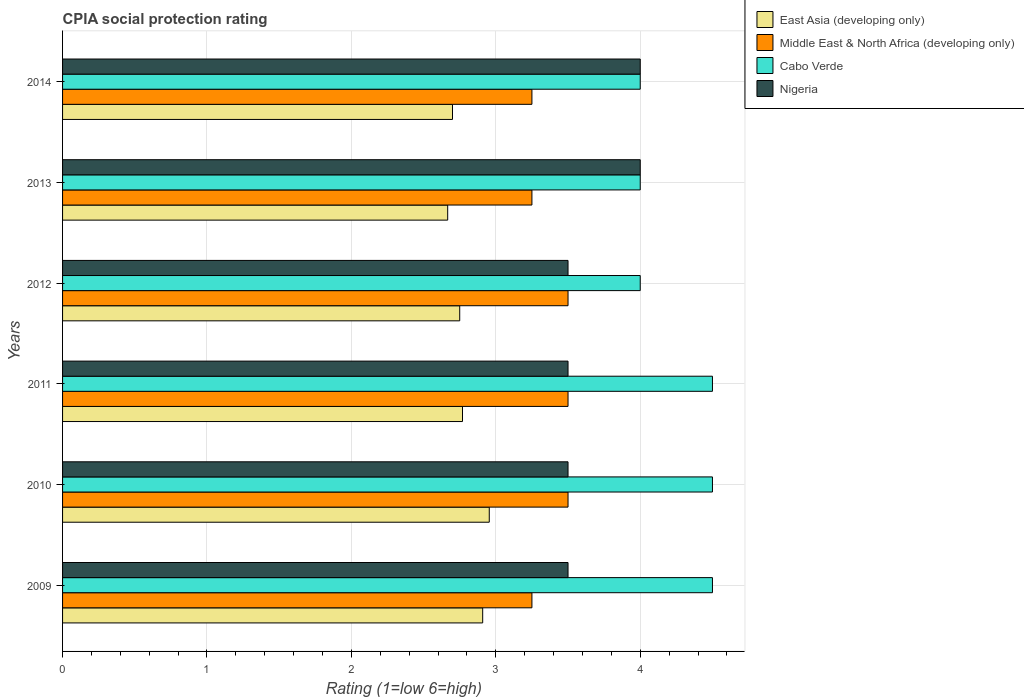How many groups of bars are there?
Your answer should be compact. 6. Are the number of bars on each tick of the Y-axis equal?
Ensure brevity in your answer.  Yes. How many bars are there on the 2nd tick from the bottom?
Make the answer very short. 4. What is the label of the 4th group of bars from the top?
Ensure brevity in your answer.  2011. What is the CPIA rating in Middle East & North Africa (developing only) in 2014?
Your answer should be very brief. 3.25. In which year was the CPIA rating in Nigeria maximum?
Provide a succinct answer. 2013. In which year was the CPIA rating in Middle East & North Africa (developing only) minimum?
Your answer should be very brief. 2009. What is the total CPIA rating in Cabo Verde in the graph?
Your answer should be compact. 25.5. What is the difference between the CPIA rating in Nigeria in 2013 and the CPIA rating in Cabo Verde in 2012?
Provide a short and direct response. 0. What is the average CPIA rating in Nigeria per year?
Your answer should be very brief. 3.67. In the year 2014, what is the difference between the CPIA rating in Nigeria and CPIA rating in East Asia (developing only)?
Offer a very short reply. 1.3. In how many years, is the CPIA rating in Middle East & North Africa (developing only) greater than 2.6 ?
Offer a terse response. 6. What is the difference between the highest and the second highest CPIA rating in East Asia (developing only)?
Your answer should be very brief. 0.05. What is the difference between the highest and the lowest CPIA rating in Cabo Verde?
Ensure brevity in your answer.  0.5. Is the sum of the CPIA rating in Middle East & North Africa (developing only) in 2010 and 2012 greater than the maximum CPIA rating in Cabo Verde across all years?
Provide a succinct answer. Yes. Is it the case that in every year, the sum of the CPIA rating in Cabo Verde and CPIA rating in Nigeria is greater than the sum of CPIA rating in Middle East & North Africa (developing only) and CPIA rating in East Asia (developing only)?
Provide a short and direct response. Yes. What does the 4th bar from the top in 2013 represents?
Give a very brief answer. East Asia (developing only). What does the 1st bar from the bottom in 2011 represents?
Offer a very short reply. East Asia (developing only). Is it the case that in every year, the sum of the CPIA rating in Cabo Verde and CPIA rating in East Asia (developing only) is greater than the CPIA rating in Nigeria?
Make the answer very short. Yes. How many bars are there?
Ensure brevity in your answer.  24. What is the difference between two consecutive major ticks on the X-axis?
Make the answer very short. 1. Does the graph contain any zero values?
Your answer should be very brief. No. Does the graph contain grids?
Keep it short and to the point. Yes. How many legend labels are there?
Your answer should be compact. 4. What is the title of the graph?
Ensure brevity in your answer.  CPIA social protection rating. Does "South Asia" appear as one of the legend labels in the graph?
Your answer should be compact. No. What is the Rating (1=low 6=high) of East Asia (developing only) in 2009?
Keep it short and to the point. 2.91. What is the Rating (1=low 6=high) in Middle East & North Africa (developing only) in 2009?
Offer a terse response. 3.25. What is the Rating (1=low 6=high) of East Asia (developing only) in 2010?
Provide a succinct answer. 2.95. What is the Rating (1=low 6=high) in Middle East & North Africa (developing only) in 2010?
Offer a terse response. 3.5. What is the Rating (1=low 6=high) in Cabo Verde in 2010?
Make the answer very short. 4.5. What is the Rating (1=low 6=high) of East Asia (developing only) in 2011?
Your answer should be compact. 2.77. What is the Rating (1=low 6=high) of Nigeria in 2011?
Provide a succinct answer. 3.5. What is the Rating (1=low 6=high) in East Asia (developing only) in 2012?
Your answer should be very brief. 2.75. What is the Rating (1=low 6=high) in Cabo Verde in 2012?
Your answer should be very brief. 4. What is the Rating (1=low 6=high) in East Asia (developing only) in 2013?
Your answer should be very brief. 2.67. What is the Rating (1=low 6=high) in Nigeria in 2013?
Keep it short and to the point. 4. What is the Rating (1=low 6=high) in Middle East & North Africa (developing only) in 2014?
Provide a succinct answer. 3.25. What is the Rating (1=low 6=high) in Nigeria in 2014?
Provide a succinct answer. 4. Across all years, what is the maximum Rating (1=low 6=high) of East Asia (developing only)?
Make the answer very short. 2.95. Across all years, what is the maximum Rating (1=low 6=high) in Cabo Verde?
Provide a succinct answer. 4.5. Across all years, what is the maximum Rating (1=low 6=high) of Nigeria?
Make the answer very short. 4. Across all years, what is the minimum Rating (1=low 6=high) of East Asia (developing only)?
Keep it short and to the point. 2.67. Across all years, what is the minimum Rating (1=low 6=high) of Middle East & North Africa (developing only)?
Keep it short and to the point. 3.25. Across all years, what is the minimum Rating (1=low 6=high) in Cabo Verde?
Provide a succinct answer. 4. Across all years, what is the minimum Rating (1=low 6=high) of Nigeria?
Your response must be concise. 3.5. What is the total Rating (1=low 6=high) of East Asia (developing only) in the graph?
Offer a very short reply. 16.75. What is the total Rating (1=low 6=high) in Middle East & North Africa (developing only) in the graph?
Offer a very short reply. 20.25. What is the total Rating (1=low 6=high) of Cabo Verde in the graph?
Make the answer very short. 25.5. What is the difference between the Rating (1=low 6=high) in East Asia (developing only) in 2009 and that in 2010?
Your answer should be compact. -0.05. What is the difference between the Rating (1=low 6=high) in Cabo Verde in 2009 and that in 2010?
Provide a short and direct response. 0. What is the difference between the Rating (1=low 6=high) of East Asia (developing only) in 2009 and that in 2011?
Offer a terse response. 0.14. What is the difference between the Rating (1=low 6=high) in Middle East & North Africa (developing only) in 2009 and that in 2011?
Make the answer very short. -0.25. What is the difference between the Rating (1=low 6=high) in East Asia (developing only) in 2009 and that in 2012?
Your answer should be very brief. 0.16. What is the difference between the Rating (1=low 6=high) in Middle East & North Africa (developing only) in 2009 and that in 2012?
Offer a very short reply. -0.25. What is the difference between the Rating (1=low 6=high) in Nigeria in 2009 and that in 2012?
Give a very brief answer. 0. What is the difference between the Rating (1=low 6=high) in East Asia (developing only) in 2009 and that in 2013?
Your response must be concise. 0.24. What is the difference between the Rating (1=low 6=high) in East Asia (developing only) in 2009 and that in 2014?
Your answer should be very brief. 0.21. What is the difference between the Rating (1=low 6=high) in East Asia (developing only) in 2010 and that in 2011?
Provide a succinct answer. 0.19. What is the difference between the Rating (1=low 6=high) of Cabo Verde in 2010 and that in 2011?
Ensure brevity in your answer.  0. What is the difference between the Rating (1=low 6=high) in East Asia (developing only) in 2010 and that in 2012?
Your answer should be compact. 0.2. What is the difference between the Rating (1=low 6=high) in Cabo Verde in 2010 and that in 2012?
Your answer should be compact. 0.5. What is the difference between the Rating (1=low 6=high) in East Asia (developing only) in 2010 and that in 2013?
Provide a short and direct response. 0.29. What is the difference between the Rating (1=low 6=high) of Middle East & North Africa (developing only) in 2010 and that in 2013?
Offer a terse response. 0.25. What is the difference between the Rating (1=low 6=high) in Cabo Verde in 2010 and that in 2013?
Make the answer very short. 0.5. What is the difference between the Rating (1=low 6=high) in East Asia (developing only) in 2010 and that in 2014?
Ensure brevity in your answer.  0.25. What is the difference between the Rating (1=low 6=high) of Cabo Verde in 2010 and that in 2014?
Your answer should be very brief. 0.5. What is the difference between the Rating (1=low 6=high) of East Asia (developing only) in 2011 and that in 2012?
Ensure brevity in your answer.  0.02. What is the difference between the Rating (1=low 6=high) of Middle East & North Africa (developing only) in 2011 and that in 2012?
Offer a terse response. 0. What is the difference between the Rating (1=low 6=high) in East Asia (developing only) in 2011 and that in 2013?
Provide a short and direct response. 0.1. What is the difference between the Rating (1=low 6=high) of East Asia (developing only) in 2011 and that in 2014?
Provide a succinct answer. 0.07. What is the difference between the Rating (1=low 6=high) of Middle East & North Africa (developing only) in 2011 and that in 2014?
Your answer should be very brief. 0.25. What is the difference between the Rating (1=low 6=high) in Cabo Verde in 2011 and that in 2014?
Keep it short and to the point. 0.5. What is the difference between the Rating (1=low 6=high) in East Asia (developing only) in 2012 and that in 2013?
Make the answer very short. 0.08. What is the difference between the Rating (1=low 6=high) in Middle East & North Africa (developing only) in 2012 and that in 2013?
Offer a terse response. 0.25. What is the difference between the Rating (1=low 6=high) in Nigeria in 2012 and that in 2013?
Your response must be concise. -0.5. What is the difference between the Rating (1=low 6=high) of East Asia (developing only) in 2012 and that in 2014?
Provide a short and direct response. 0.05. What is the difference between the Rating (1=low 6=high) of East Asia (developing only) in 2013 and that in 2014?
Provide a succinct answer. -0.03. What is the difference between the Rating (1=low 6=high) in East Asia (developing only) in 2009 and the Rating (1=low 6=high) in Middle East & North Africa (developing only) in 2010?
Your answer should be compact. -0.59. What is the difference between the Rating (1=low 6=high) in East Asia (developing only) in 2009 and the Rating (1=low 6=high) in Cabo Verde in 2010?
Keep it short and to the point. -1.59. What is the difference between the Rating (1=low 6=high) in East Asia (developing only) in 2009 and the Rating (1=low 6=high) in Nigeria in 2010?
Your response must be concise. -0.59. What is the difference between the Rating (1=low 6=high) in Middle East & North Africa (developing only) in 2009 and the Rating (1=low 6=high) in Cabo Verde in 2010?
Provide a short and direct response. -1.25. What is the difference between the Rating (1=low 6=high) of Cabo Verde in 2009 and the Rating (1=low 6=high) of Nigeria in 2010?
Make the answer very short. 1. What is the difference between the Rating (1=low 6=high) in East Asia (developing only) in 2009 and the Rating (1=low 6=high) in Middle East & North Africa (developing only) in 2011?
Ensure brevity in your answer.  -0.59. What is the difference between the Rating (1=low 6=high) of East Asia (developing only) in 2009 and the Rating (1=low 6=high) of Cabo Verde in 2011?
Your response must be concise. -1.59. What is the difference between the Rating (1=low 6=high) in East Asia (developing only) in 2009 and the Rating (1=low 6=high) in Nigeria in 2011?
Give a very brief answer. -0.59. What is the difference between the Rating (1=low 6=high) of Middle East & North Africa (developing only) in 2009 and the Rating (1=low 6=high) of Cabo Verde in 2011?
Offer a very short reply. -1.25. What is the difference between the Rating (1=low 6=high) in Cabo Verde in 2009 and the Rating (1=low 6=high) in Nigeria in 2011?
Your response must be concise. 1. What is the difference between the Rating (1=low 6=high) in East Asia (developing only) in 2009 and the Rating (1=low 6=high) in Middle East & North Africa (developing only) in 2012?
Provide a short and direct response. -0.59. What is the difference between the Rating (1=low 6=high) in East Asia (developing only) in 2009 and the Rating (1=low 6=high) in Cabo Verde in 2012?
Keep it short and to the point. -1.09. What is the difference between the Rating (1=low 6=high) in East Asia (developing only) in 2009 and the Rating (1=low 6=high) in Nigeria in 2012?
Offer a very short reply. -0.59. What is the difference between the Rating (1=low 6=high) in Middle East & North Africa (developing only) in 2009 and the Rating (1=low 6=high) in Cabo Verde in 2012?
Your answer should be very brief. -0.75. What is the difference between the Rating (1=low 6=high) in Cabo Verde in 2009 and the Rating (1=low 6=high) in Nigeria in 2012?
Offer a terse response. 1. What is the difference between the Rating (1=low 6=high) of East Asia (developing only) in 2009 and the Rating (1=low 6=high) of Middle East & North Africa (developing only) in 2013?
Keep it short and to the point. -0.34. What is the difference between the Rating (1=low 6=high) of East Asia (developing only) in 2009 and the Rating (1=low 6=high) of Cabo Verde in 2013?
Provide a succinct answer. -1.09. What is the difference between the Rating (1=low 6=high) of East Asia (developing only) in 2009 and the Rating (1=low 6=high) of Nigeria in 2013?
Your answer should be compact. -1.09. What is the difference between the Rating (1=low 6=high) of Middle East & North Africa (developing only) in 2009 and the Rating (1=low 6=high) of Cabo Verde in 2013?
Provide a short and direct response. -0.75. What is the difference between the Rating (1=low 6=high) of Middle East & North Africa (developing only) in 2009 and the Rating (1=low 6=high) of Nigeria in 2013?
Offer a very short reply. -0.75. What is the difference between the Rating (1=low 6=high) of Cabo Verde in 2009 and the Rating (1=low 6=high) of Nigeria in 2013?
Make the answer very short. 0.5. What is the difference between the Rating (1=low 6=high) in East Asia (developing only) in 2009 and the Rating (1=low 6=high) in Middle East & North Africa (developing only) in 2014?
Ensure brevity in your answer.  -0.34. What is the difference between the Rating (1=low 6=high) in East Asia (developing only) in 2009 and the Rating (1=low 6=high) in Cabo Verde in 2014?
Give a very brief answer. -1.09. What is the difference between the Rating (1=low 6=high) in East Asia (developing only) in 2009 and the Rating (1=low 6=high) in Nigeria in 2014?
Make the answer very short. -1.09. What is the difference between the Rating (1=low 6=high) in Middle East & North Africa (developing only) in 2009 and the Rating (1=low 6=high) in Cabo Verde in 2014?
Make the answer very short. -0.75. What is the difference between the Rating (1=low 6=high) in Middle East & North Africa (developing only) in 2009 and the Rating (1=low 6=high) in Nigeria in 2014?
Ensure brevity in your answer.  -0.75. What is the difference between the Rating (1=low 6=high) in East Asia (developing only) in 2010 and the Rating (1=low 6=high) in Middle East & North Africa (developing only) in 2011?
Keep it short and to the point. -0.55. What is the difference between the Rating (1=low 6=high) in East Asia (developing only) in 2010 and the Rating (1=low 6=high) in Cabo Verde in 2011?
Provide a succinct answer. -1.55. What is the difference between the Rating (1=low 6=high) in East Asia (developing only) in 2010 and the Rating (1=low 6=high) in Nigeria in 2011?
Your response must be concise. -0.55. What is the difference between the Rating (1=low 6=high) in Cabo Verde in 2010 and the Rating (1=low 6=high) in Nigeria in 2011?
Provide a short and direct response. 1. What is the difference between the Rating (1=low 6=high) of East Asia (developing only) in 2010 and the Rating (1=low 6=high) of Middle East & North Africa (developing only) in 2012?
Your answer should be very brief. -0.55. What is the difference between the Rating (1=low 6=high) of East Asia (developing only) in 2010 and the Rating (1=low 6=high) of Cabo Verde in 2012?
Ensure brevity in your answer.  -1.05. What is the difference between the Rating (1=low 6=high) of East Asia (developing only) in 2010 and the Rating (1=low 6=high) of Nigeria in 2012?
Give a very brief answer. -0.55. What is the difference between the Rating (1=low 6=high) in Middle East & North Africa (developing only) in 2010 and the Rating (1=low 6=high) in Nigeria in 2012?
Your answer should be compact. 0. What is the difference between the Rating (1=low 6=high) in East Asia (developing only) in 2010 and the Rating (1=low 6=high) in Middle East & North Africa (developing only) in 2013?
Your response must be concise. -0.3. What is the difference between the Rating (1=low 6=high) in East Asia (developing only) in 2010 and the Rating (1=low 6=high) in Cabo Verde in 2013?
Provide a succinct answer. -1.05. What is the difference between the Rating (1=low 6=high) of East Asia (developing only) in 2010 and the Rating (1=low 6=high) of Nigeria in 2013?
Give a very brief answer. -1.05. What is the difference between the Rating (1=low 6=high) of Middle East & North Africa (developing only) in 2010 and the Rating (1=low 6=high) of Nigeria in 2013?
Keep it short and to the point. -0.5. What is the difference between the Rating (1=low 6=high) in Cabo Verde in 2010 and the Rating (1=low 6=high) in Nigeria in 2013?
Offer a terse response. 0.5. What is the difference between the Rating (1=low 6=high) in East Asia (developing only) in 2010 and the Rating (1=low 6=high) in Middle East & North Africa (developing only) in 2014?
Your answer should be compact. -0.3. What is the difference between the Rating (1=low 6=high) of East Asia (developing only) in 2010 and the Rating (1=low 6=high) of Cabo Verde in 2014?
Offer a very short reply. -1.05. What is the difference between the Rating (1=low 6=high) of East Asia (developing only) in 2010 and the Rating (1=low 6=high) of Nigeria in 2014?
Make the answer very short. -1.05. What is the difference between the Rating (1=low 6=high) in Middle East & North Africa (developing only) in 2010 and the Rating (1=low 6=high) in Nigeria in 2014?
Offer a very short reply. -0.5. What is the difference between the Rating (1=low 6=high) in Cabo Verde in 2010 and the Rating (1=low 6=high) in Nigeria in 2014?
Make the answer very short. 0.5. What is the difference between the Rating (1=low 6=high) of East Asia (developing only) in 2011 and the Rating (1=low 6=high) of Middle East & North Africa (developing only) in 2012?
Ensure brevity in your answer.  -0.73. What is the difference between the Rating (1=low 6=high) of East Asia (developing only) in 2011 and the Rating (1=low 6=high) of Cabo Verde in 2012?
Your response must be concise. -1.23. What is the difference between the Rating (1=low 6=high) of East Asia (developing only) in 2011 and the Rating (1=low 6=high) of Nigeria in 2012?
Your answer should be compact. -0.73. What is the difference between the Rating (1=low 6=high) of Middle East & North Africa (developing only) in 2011 and the Rating (1=low 6=high) of Nigeria in 2012?
Provide a succinct answer. 0. What is the difference between the Rating (1=low 6=high) of East Asia (developing only) in 2011 and the Rating (1=low 6=high) of Middle East & North Africa (developing only) in 2013?
Your response must be concise. -0.48. What is the difference between the Rating (1=low 6=high) of East Asia (developing only) in 2011 and the Rating (1=low 6=high) of Cabo Verde in 2013?
Your answer should be very brief. -1.23. What is the difference between the Rating (1=low 6=high) in East Asia (developing only) in 2011 and the Rating (1=low 6=high) in Nigeria in 2013?
Give a very brief answer. -1.23. What is the difference between the Rating (1=low 6=high) of Middle East & North Africa (developing only) in 2011 and the Rating (1=low 6=high) of Nigeria in 2013?
Your answer should be very brief. -0.5. What is the difference between the Rating (1=low 6=high) of East Asia (developing only) in 2011 and the Rating (1=low 6=high) of Middle East & North Africa (developing only) in 2014?
Ensure brevity in your answer.  -0.48. What is the difference between the Rating (1=low 6=high) of East Asia (developing only) in 2011 and the Rating (1=low 6=high) of Cabo Verde in 2014?
Your answer should be very brief. -1.23. What is the difference between the Rating (1=low 6=high) in East Asia (developing only) in 2011 and the Rating (1=low 6=high) in Nigeria in 2014?
Your response must be concise. -1.23. What is the difference between the Rating (1=low 6=high) of East Asia (developing only) in 2012 and the Rating (1=low 6=high) of Middle East & North Africa (developing only) in 2013?
Offer a very short reply. -0.5. What is the difference between the Rating (1=low 6=high) of East Asia (developing only) in 2012 and the Rating (1=low 6=high) of Cabo Verde in 2013?
Offer a very short reply. -1.25. What is the difference between the Rating (1=low 6=high) of East Asia (developing only) in 2012 and the Rating (1=low 6=high) of Nigeria in 2013?
Keep it short and to the point. -1.25. What is the difference between the Rating (1=low 6=high) in East Asia (developing only) in 2012 and the Rating (1=low 6=high) in Cabo Verde in 2014?
Offer a terse response. -1.25. What is the difference between the Rating (1=low 6=high) of East Asia (developing only) in 2012 and the Rating (1=low 6=high) of Nigeria in 2014?
Your answer should be very brief. -1.25. What is the difference between the Rating (1=low 6=high) in Middle East & North Africa (developing only) in 2012 and the Rating (1=low 6=high) in Cabo Verde in 2014?
Provide a short and direct response. -0.5. What is the difference between the Rating (1=low 6=high) of Middle East & North Africa (developing only) in 2012 and the Rating (1=low 6=high) of Nigeria in 2014?
Make the answer very short. -0.5. What is the difference between the Rating (1=low 6=high) in East Asia (developing only) in 2013 and the Rating (1=low 6=high) in Middle East & North Africa (developing only) in 2014?
Ensure brevity in your answer.  -0.58. What is the difference between the Rating (1=low 6=high) in East Asia (developing only) in 2013 and the Rating (1=low 6=high) in Cabo Verde in 2014?
Keep it short and to the point. -1.33. What is the difference between the Rating (1=low 6=high) of East Asia (developing only) in 2013 and the Rating (1=low 6=high) of Nigeria in 2014?
Ensure brevity in your answer.  -1.33. What is the difference between the Rating (1=low 6=high) of Middle East & North Africa (developing only) in 2013 and the Rating (1=low 6=high) of Cabo Verde in 2014?
Ensure brevity in your answer.  -0.75. What is the difference between the Rating (1=low 6=high) in Middle East & North Africa (developing only) in 2013 and the Rating (1=low 6=high) in Nigeria in 2014?
Your response must be concise. -0.75. What is the difference between the Rating (1=low 6=high) of Cabo Verde in 2013 and the Rating (1=low 6=high) of Nigeria in 2014?
Offer a very short reply. 0. What is the average Rating (1=low 6=high) in East Asia (developing only) per year?
Your response must be concise. 2.79. What is the average Rating (1=low 6=high) in Middle East & North Africa (developing only) per year?
Ensure brevity in your answer.  3.38. What is the average Rating (1=low 6=high) of Cabo Verde per year?
Keep it short and to the point. 4.25. What is the average Rating (1=low 6=high) of Nigeria per year?
Offer a terse response. 3.67. In the year 2009, what is the difference between the Rating (1=low 6=high) of East Asia (developing only) and Rating (1=low 6=high) of Middle East & North Africa (developing only)?
Give a very brief answer. -0.34. In the year 2009, what is the difference between the Rating (1=low 6=high) in East Asia (developing only) and Rating (1=low 6=high) in Cabo Verde?
Your answer should be very brief. -1.59. In the year 2009, what is the difference between the Rating (1=low 6=high) in East Asia (developing only) and Rating (1=low 6=high) in Nigeria?
Your answer should be compact. -0.59. In the year 2009, what is the difference between the Rating (1=low 6=high) in Middle East & North Africa (developing only) and Rating (1=low 6=high) in Cabo Verde?
Provide a succinct answer. -1.25. In the year 2010, what is the difference between the Rating (1=low 6=high) in East Asia (developing only) and Rating (1=low 6=high) in Middle East & North Africa (developing only)?
Keep it short and to the point. -0.55. In the year 2010, what is the difference between the Rating (1=low 6=high) in East Asia (developing only) and Rating (1=low 6=high) in Cabo Verde?
Your answer should be very brief. -1.55. In the year 2010, what is the difference between the Rating (1=low 6=high) of East Asia (developing only) and Rating (1=low 6=high) of Nigeria?
Keep it short and to the point. -0.55. In the year 2010, what is the difference between the Rating (1=low 6=high) in Cabo Verde and Rating (1=low 6=high) in Nigeria?
Your answer should be compact. 1. In the year 2011, what is the difference between the Rating (1=low 6=high) in East Asia (developing only) and Rating (1=low 6=high) in Middle East & North Africa (developing only)?
Offer a terse response. -0.73. In the year 2011, what is the difference between the Rating (1=low 6=high) in East Asia (developing only) and Rating (1=low 6=high) in Cabo Verde?
Your answer should be compact. -1.73. In the year 2011, what is the difference between the Rating (1=low 6=high) of East Asia (developing only) and Rating (1=low 6=high) of Nigeria?
Ensure brevity in your answer.  -0.73. In the year 2011, what is the difference between the Rating (1=low 6=high) of Middle East & North Africa (developing only) and Rating (1=low 6=high) of Cabo Verde?
Offer a terse response. -1. In the year 2011, what is the difference between the Rating (1=low 6=high) in Middle East & North Africa (developing only) and Rating (1=low 6=high) in Nigeria?
Make the answer very short. 0. In the year 2012, what is the difference between the Rating (1=low 6=high) in East Asia (developing only) and Rating (1=low 6=high) in Middle East & North Africa (developing only)?
Make the answer very short. -0.75. In the year 2012, what is the difference between the Rating (1=low 6=high) in East Asia (developing only) and Rating (1=low 6=high) in Cabo Verde?
Your answer should be very brief. -1.25. In the year 2012, what is the difference between the Rating (1=low 6=high) in East Asia (developing only) and Rating (1=low 6=high) in Nigeria?
Offer a very short reply. -0.75. In the year 2013, what is the difference between the Rating (1=low 6=high) of East Asia (developing only) and Rating (1=low 6=high) of Middle East & North Africa (developing only)?
Provide a succinct answer. -0.58. In the year 2013, what is the difference between the Rating (1=low 6=high) of East Asia (developing only) and Rating (1=low 6=high) of Cabo Verde?
Your response must be concise. -1.33. In the year 2013, what is the difference between the Rating (1=low 6=high) of East Asia (developing only) and Rating (1=low 6=high) of Nigeria?
Make the answer very short. -1.33. In the year 2013, what is the difference between the Rating (1=low 6=high) of Middle East & North Africa (developing only) and Rating (1=low 6=high) of Cabo Verde?
Your response must be concise. -0.75. In the year 2013, what is the difference between the Rating (1=low 6=high) in Middle East & North Africa (developing only) and Rating (1=low 6=high) in Nigeria?
Make the answer very short. -0.75. In the year 2013, what is the difference between the Rating (1=low 6=high) of Cabo Verde and Rating (1=low 6=high) of Nigeria?
Ensure brevity in your answer.  0. In the year 2014, what is the difference between the Rating (1=low 6=high) in East Asia (developing only) and Rating (1=low 6=high) in Middle East & North Africa (developing only)?
Keep it short and to the point. -0.55. In the year 2014, what is the difference between the Rating (1=low 6=high) in East Asia (developing only) and Rating (1=low 6=high) in Cabo Verde?
Your response must be concise. -1.3. In the year 2014, what is the difference between the Rating (1=low 6=high) in East Asia (developing only) and Rating (1=low 6=high) in Nigeria?
Provide a short and direct response. -1.3. In the year 2014, what is the difference between the Rating (1=low 6=high) of Middle East & North Africa (developing only) and Rating (1=low 6=high) of Cabo Verde?
Offer a very short reply. -0.75. In the year 2014, what is the difference between the Rating (1=low 6=high) in Middle East & North Africa (developing only) and Rating (1=low 6=high) in Nigeria?
Your response must be concise. -0.75. In the year 2014, what is the difference between the Rating (1=low 6=high) of Cabo Verde and Rating (1=low 6=high) of Nigeria?
Provide a succinct answer. 0. What is the ratio of the Rating (1=low 6=high) of East Asia (developing only) in 2009 to that in 2010?
Offer a terse response. 0.98. What is the ratio of the Rating (1=low 6=high) in Middle East & North Africa (developing only) in 2009 to that in 2010?
Give a very brief answer. 0.93. What is the ratio of the Rating (1=low 6=high) of East Asia (developing only) in 2009 to that in 2011?
Provide a succinct answer. 1.05. What is the ratio of the Rating (1=low 6=high) in Middle East & North Africa (developing only) in 2009 to that in 2011?
Your answer should be very brief. 0.93. What is the ratio of the Rating (1=low 6=high) of Cabo Verde in 2009 to that in 2011?
Provide a short and direct response. 1. What is the ratio of the Rating (1=low 6=high) in East Asia (developing only) in 2009 to that in 2012?
Offer a very short reply. 1.06. What is the ratio of the Rating (1=low 6=high) in Middle East & North Africa (developing only) in 2009 to that in 2012?
Provide a succinct answer. 0.93. What is the ratio of the Rating (1=low 6=high) in Cabo Verde in 2009 to that in 2012?
Ensure brevity in your answer.  1.12. What is the ratio of the Rating (1=low 6=high) of Nigeria in 2009 to that in 2012?
Ensure brevity in your answer.  1. What is the ratio of the Rating (1=low 6=high) in Cabo Verde in 2009 to that in 2013?
Make the answer very short. 1.12. What is the ratio of the Rating (1=low 6=high) of East Asia (developing only) in 2009 to that in 2014?
Keep it short and to the point. 1.08. What is the ratio of the Rating (1=low 6=high) of Cabo Verde in 2009 to that in 2014?
Offer a very short reply. 1.12. What is the ratio of the Rating (1=low 6=high) of Nigeria in 2009 to that in 2014?
Your response must be concise. 0.88. What is the ratio of the Rating (1=low 6=high) of East Asia (developing only) in 2010 to that in 2011?
Provide a succinct answer. 1.07. What is the ratio of the Rating (1=low 6=high) in Middle East & North Africa (developing only) in 2010 to that in 2011?
Your response must be concise. 1. What is the ratio of the Rating (1=low 6=high) in Cabo Verde in 2010 to that in 2011?
Provide a succinct answer. 1. What is the ratio of the Rating (1=low 6=high) of East Asia (developing only) in 2010 to that in 2012?
Keep it short and to the point. 1.07. What is the ratio of the Rating (1=low 6=high) in Cabo Verde in 2010 to that in 2012?
Keep it short and to the point. 1.12. What is the ratio of the Rating (1=low 6=high) in East Asia (developing only) in 2010 to that in 2013?
Give a very brief answer. 1.11. What is the ratio of the Rating (1=low 6=high) of Middle East & North Africa (developing only) in 2010 to that in 2013?
Your answer should be compact. 1.08. What is the ratio of the Rating (1=low 6=high) of Cabo Verde in 2010 to that in 2013?
Give a very brief answer. 1.12. What is the ratio of the Rating (1=low 6=high) of Nigeria in 2010 to that in 2013?
Your response must be concise. 0.88. What is the ratio of the Rating (1=low 6=high) in East Asia (developing only) in 2010 to that in 2014?
Your answer should be compact. 1.09. What is the ratio of the Rating (1=low 6=high) of Middle East & North Africa (developing only) in 2010 to that in 2014?
Provide a succinct answer. 1.08. What is the ratio of the Rating (1=low 6=high) in Cabo Verde in 2011 to that in 2012?
Your answer should be very brief. 1.12. What is the ratio of the Rating (1=low 6=high) of Nigeria in 2011 to that in 2012?
Your answer should be compact. 1. What is the ratio of the Rating (1=low 6=high) of Nigeria in 2011 to that in 2013?
Your answer should be compact. 0.88. What is the ratio of the Rating (1=low 6=high) of East Asia (developing only) in 2011 to that in 2014?
Your answer should be very brief. 1.03. What is the ratio of the Rating (1=low 6=high) in Middle East & North Africa (developing only) in 2011 to that in 2014?
Keep it short and to the point. 1.08. What is the ratio of the Rating (1=low 6=high) in Nigeria in 2011 to that in 2014?
Keep it short and to the point. 0.88. What is the ratio of the Rating (1=low 6=high) in East Asia (developing only) in 2012 to that in 2013?
Ensure brevity in your answer.  1.03. What is the ratio of the Rating (1=low 6=high) in East Asia (developing only) in 2012 to that in 2014?
Provide a succinct answer. 1.02. What is the ratio of the Rating (1=low 6=high) of Cabo Verde in 2012 to that in 2014?
Provide a succinct answer. 1. What is the ratio of the Rating (1=low 6=high) of Nigeria in 2012 to that in 2014?
Your answer should be compact. 0.88. What is the ratio of the Rating (1=low 6=high) in Middle East & North Africa (developing only) in 2013 to that in 2014?
Provide a short and direct response. 1. What is the ratio of the Rating (1=low 6=high) of Cabo Verde in 2013 to that in 2014?
Your answer should be compact. 1. What is the difference between the highest and the second highest Rating (1=low 6=high) in East Asia (developing only)?
Provide a short and direct response. 0.05. What is the difference between the highest and the lowest Rating (1=low 6=high) of East Asia (developing only)?
Provide a succinct answer. 0.29. What is the difference between the highest and the lowest Rating (1=low 6=high) of Cabo Verde?
Your answer should be very brief. 0.5. What is the difference between the highest and the lowest Rating (1=low 6=high) in Nigeria?
Your answer should be very brief. 0.5. 